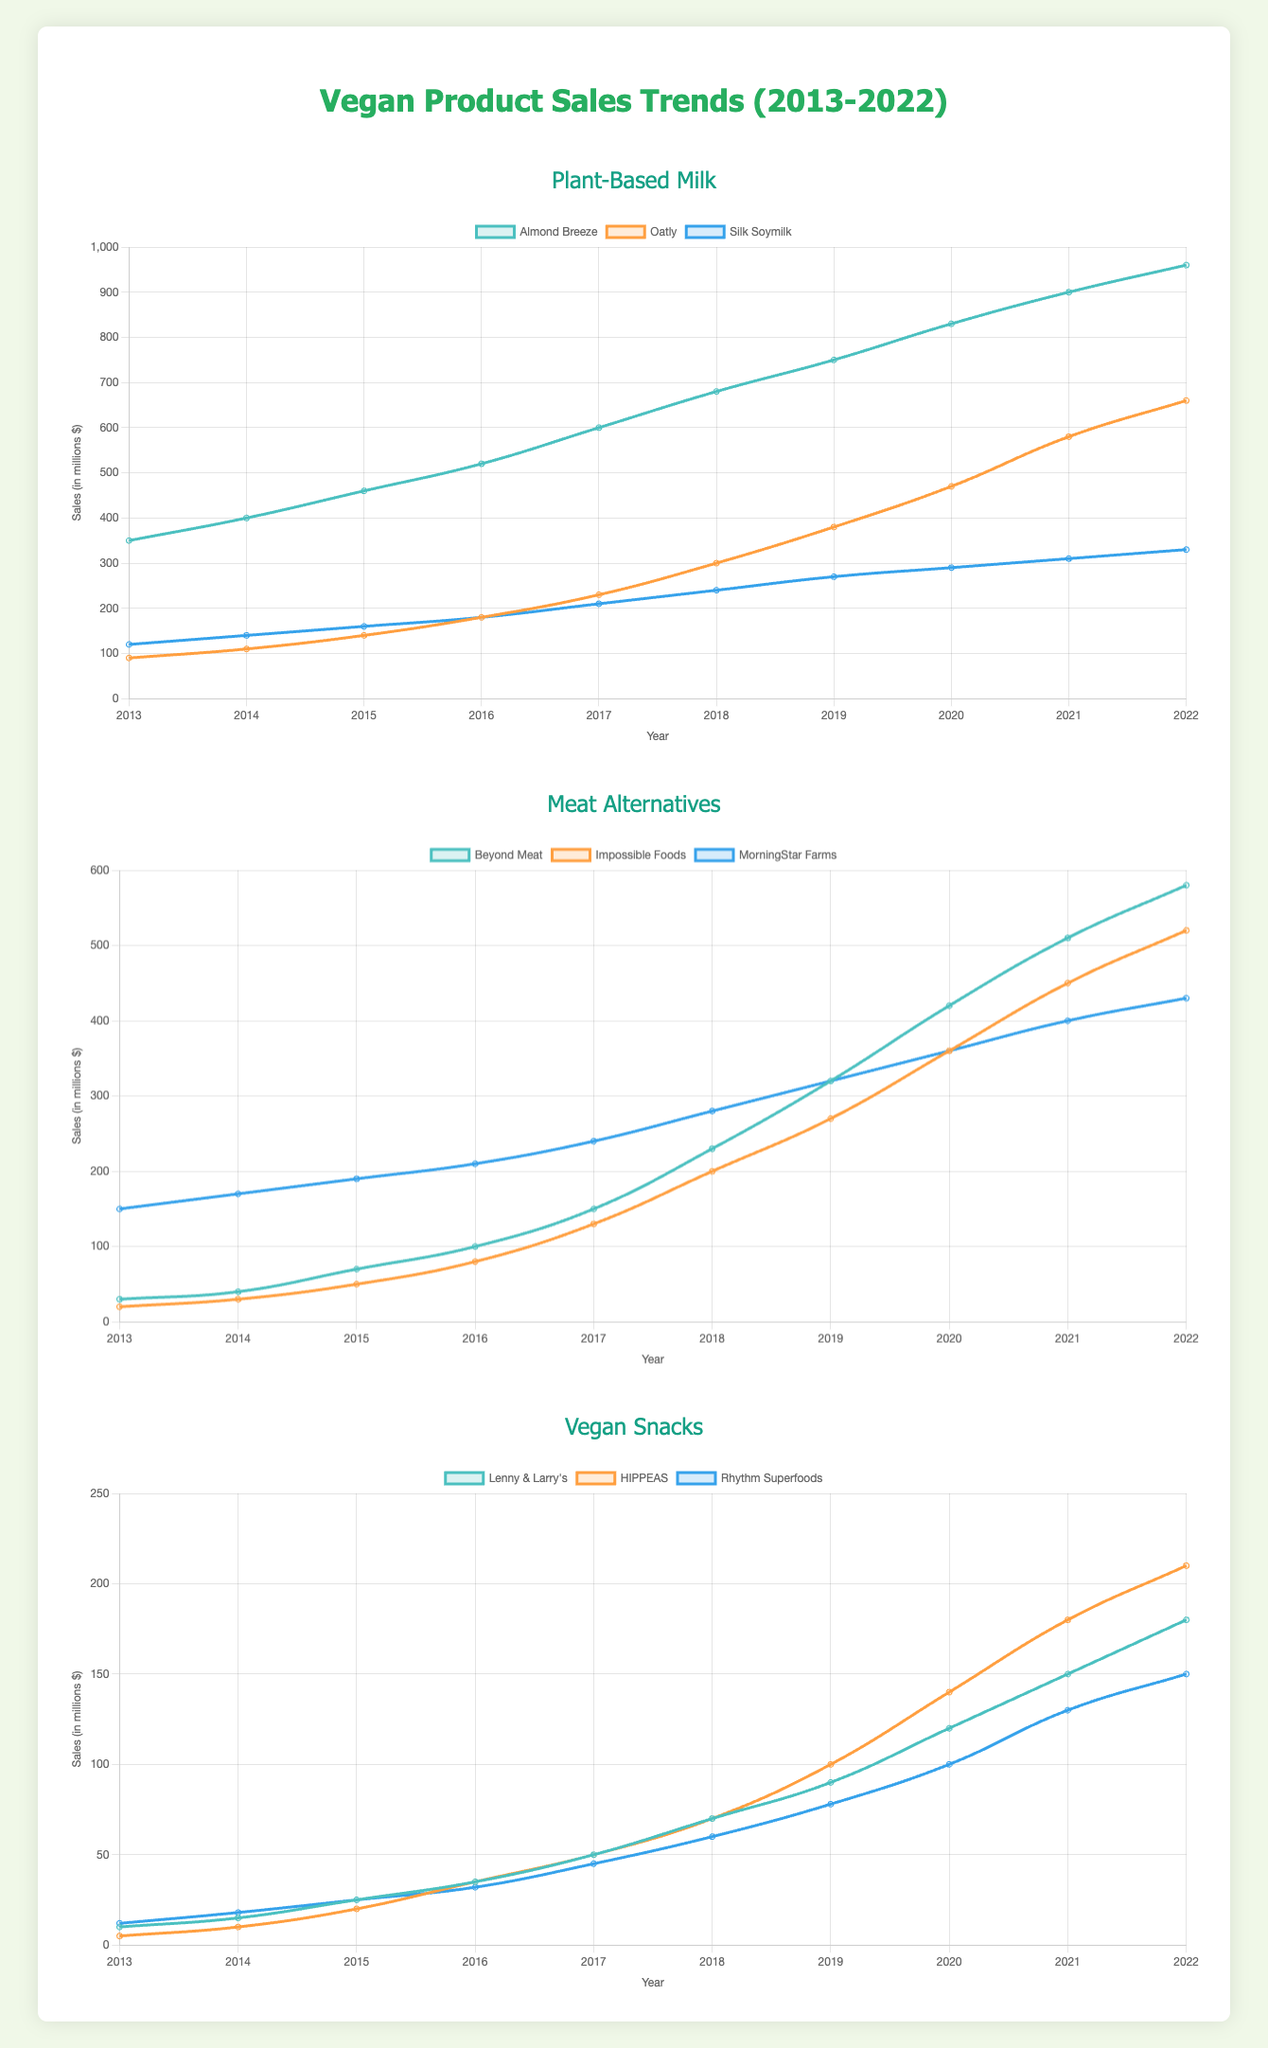Which brand of Plant-Based Milk had the highest sales in 2022? From the Plant-Based Milk chart, observe the endpoint of each line for 2022. The line for Almond Breeze reaches the highest point at 960 million dollars.
Answer: Almond Breeze What's the total sales of Beyond Meat over the decade? Add the sales values for Beyond Meat: 30 + 40 + 70 + 100 + 150 + 230 + 320 + 420 + 510 + 580, which gives 2450 million dollars.
Answer: 2450 million dollars Which brand in the Meat Alternatives category saw the highest increase in sales from 2013 to 2022? Calculate the difference between 2022 and 2013 sales for each brand. Beyond Meat: 580 - 30 = 550, Impossible Foods: 520 - 20 = 500, MorningStar Farms: 430 - 150 = 280. Beyond Meat has the highest increase of 550 million dollars.
Answer: Beyond Meat For Vegan Snacks, which brand's sales surpassed both of its competitors first, and in what year? Compare sales year-over-year for each brand. HIPPEAS surpasses both Lenny & Larry's and Rhythm Superfoods in 2021 with 180 million dollars.
Answer: HIPPEAS, 2021 What's the average annual sales of Oatly from 2013 to 2022? Sum the sales from 2013 to 2022 for Oatly (90 + 110 + 140 + 180 + 230 + 300 + 380 + 470 + 580 + 660) to get 3140. Divide by 10 years to get an average of 314.
Answer: 314 million dollars Which brand among Plant-Based Milk had the smallest overall growth over the decade? Calculate the difference between 2022 and 2013 sales for each brand. Almond Breeze: 960 - 350 = 610, Oatly: 660 - 90 = 570, Silk Soymilk: 330 - 120 = 210. Silk Soymilk had the smallest growth of 210 million dollars.
Answer: Silk Soymilk If we combine the sales of all Vegan Snacks in 2017, how much would it be? Sum the sales for each brand in 2017: Lenny & Larry's (50), HIPPEAS (50), Rhythm Superfoods (45). 50 + 50 + 45 = 145 million dollars.
Answer: 145 million dollars How did Impossible Foods' sales compare to MorningStar Farms' sales in 2020? Notice the sales points in 2020 for both brands. Impossible Foods had 360 million dollars and MorningStar Farms had 360 million dollars as well, making their sales equal in 2020.
Answer: Equal Which category had the highest cumulative sales in 2020? Sum the sales for each brand within a category in 2020. Plant-Based Milk: (830 + 470 + 290) = 1590, Meat Alternatives: (420 + 360 + 360) = 1140, Vegan Snacks: (120 + 140 + 100) = 360. Plant-Based Milk has the highest sales with 1590 million dollars.
Answer: Plant-Based Milk 